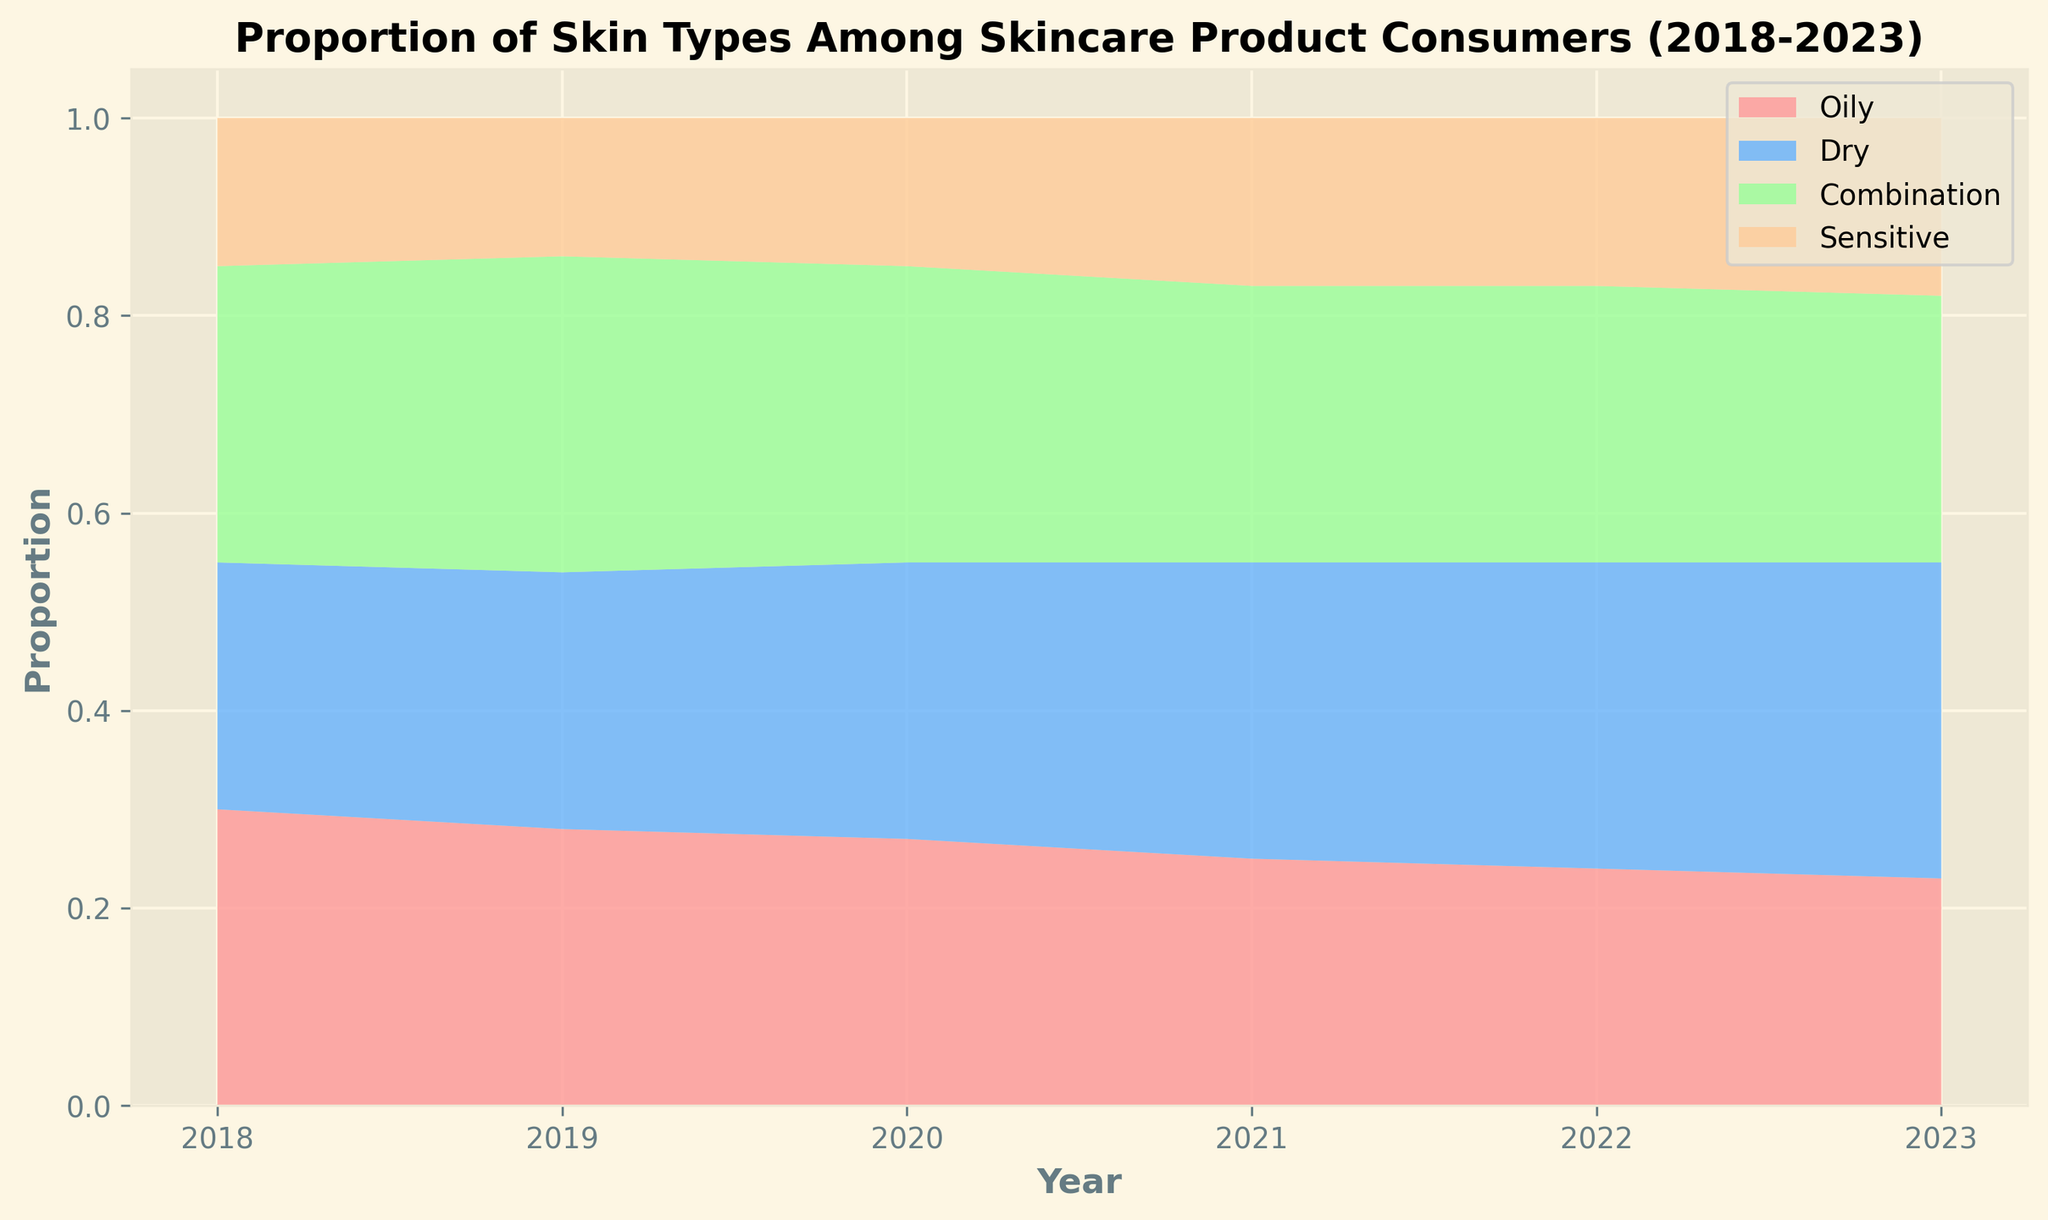What is the overall trend in the proportion of dry skin from 2018 to 2023? Plot the values of dry skin from 2018 to 2023. Notice that the values consistently increase over the years: 0.25, 0.26, 0.28, 0.30, 0.31, 0.32. This indicates an upward trend.
Answer: Upward trend How has the proportion of sensitive skin consumers changed from 2018 to 2023? Examine the proportion of sensitive skin over the years: in 2018, it was 0.15, which decreased slightly in 2019 to 0.14, then increased to 0.15 in 2020, and continued rising to 0.17 in both 2021 and 2022, and finally to 0.18 in 2023.
Answer: Increased slightly Which skin type had the highest proportion in 2023? Refer to the proportions for 2023. Oily: 0.23, Dry: 0.32, Combination: 0.27, Sensitive: 0.18. Dry skin has the highest proportion at 0.32.
Answer: Dry How did the proportion of oily skin compare from 2018 to 2021? Compare the proportions for oily skin from 2018 (0.30) to 2021 (0.25). It's clear that the proportion decreased over these years.
Answer: Decreased What is the difference in the proportion of combination skin between 2019 and 2023? Refer to the proportions of combination skin. In 2019, it was 0.32, and in 2023, it was 0.27. The difference is 0.32 - 0.27 = 0.05.
Answer: 0.05 Which skin type showed the least change in proportion from 2018 to 2023? Calculate the change for each skin type between 2018 and 2023: Oily: 0.30 - 0.23 = 0.07, Dry: 0.32 - 0.25 = 0.07, Combination: 0.30 - 0.27 = 0.03, Sensitive: 0.18 - 0.15 = 0.03. Sensitive skin and combination skin both showed the least change of 0.03.
Answer: Combination and sensitive What color represents the combination skin type in the chart? The colors used for the skin types are: Oily: red, Dry: blue, Combination: green, Sensitive: orange.
Answer: Green What trend is observed for the proportions of oily skin and dry skin over the years? Observe the visual area representing oily skin which decreases over the years while the area for dry skin increases.
Answer: Oily decreases, Dry increases Which year shows the least total proportion for combination and sensitive skin types combined? To find the least total proportion, sum the combination and sensitive skin proportions for each year:
2018: 0.30 + 0.15 = 0.45, 
2019: 0.32 + 0.14 = 0.46,
2020: 0.30 + 0.15 = 0.45,
2021: 0.28 + 0.17 = 0.45,
2022: 0.28 + 0.17 = 0.45,
2023: 0.27 + 0.18 = 0.45.
From this, the years 2018, 2020, 2021, 2022, and 2023 all have the least combined value of 0.45.
Answer: 2018, 2020, 2021, 2022, and 2023 What can you infer from the color areas for sensitive skin from 2018 to 2023? The orange area representing sensitive skin has increased slightly over the years, indicating a gradual increase in its proportion.
Answer: Gradual increase 